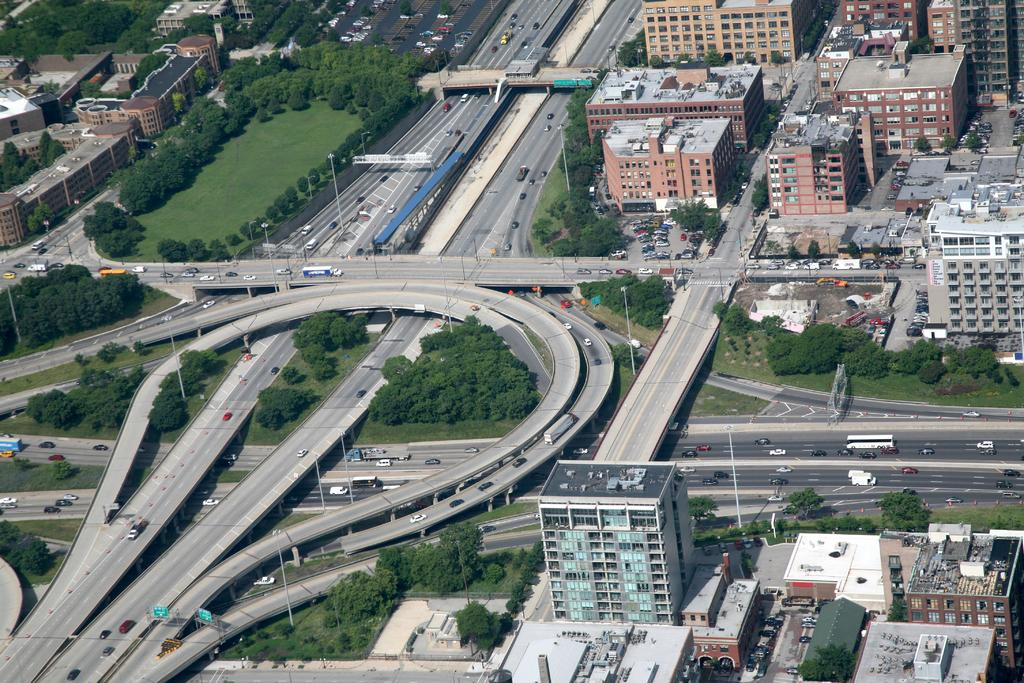What type of vegetation can be seen in the image? There are trees in the image. What type of structures are visible in the image? There are buildings in the image. What is moving on the roads in the image? Vehicles are present on the roads in the image. What type of ground cover is visible in the image? The grass is visible in the image. What type of lighting is present in the image? Street lights are present in the image. Where is the playground located in the image? There is no playground present in the image. Can you describe the person walking their dog in the image? There is no person or dog present in the image. 